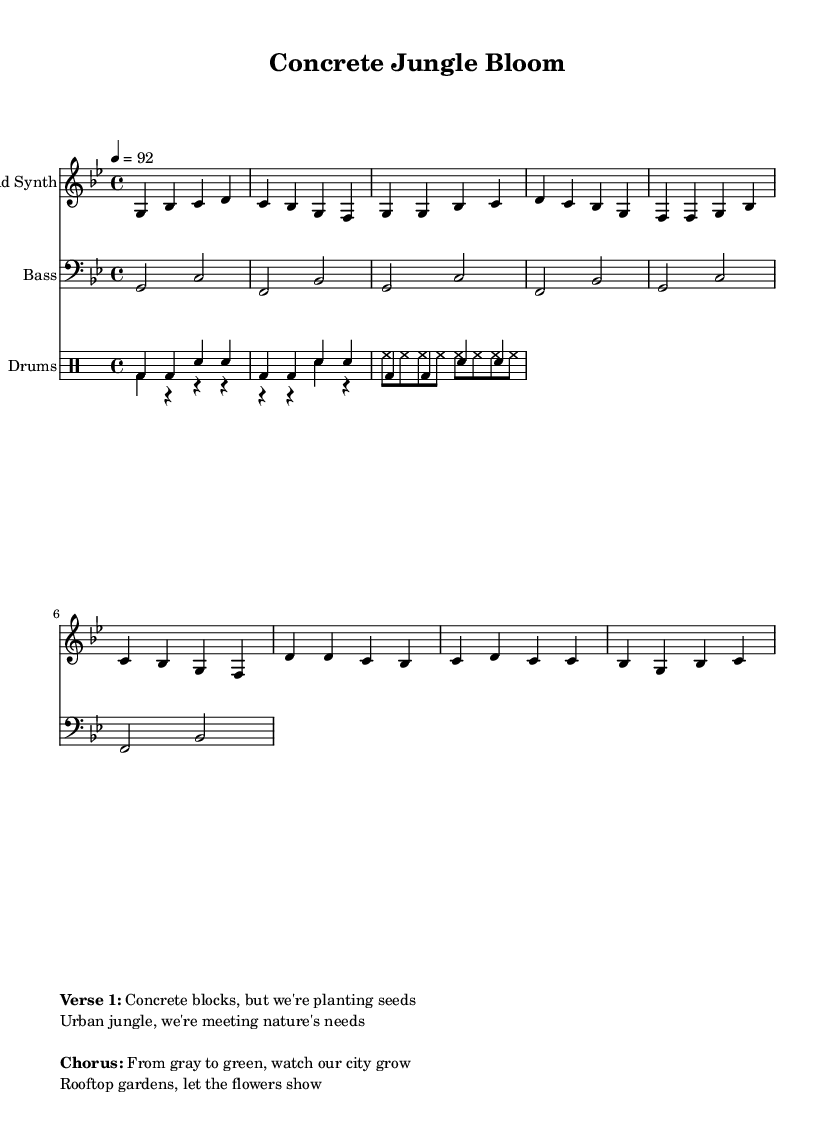What is the key signature of this music? The key signature of the music is indicated at the beginning of the score. Here, it shows two flats, meaning that it is in G minor.
Answer: G minor What is the time signature of this music? The time signature is located at the start of the piece and denotes the rhythmic structure. In this case, it is 4/4, which means there are four beats in a measure, and the quarter note gets one beat.
Answer: 4/4 What is the tempo marking of this piece? The tempo is specified near the beginning of the score with a numerical marking. It indicates that the piece should be played at a speed of 92 beats per minute.
Answer: 92 How many measures are in the verse section? To find this, we must count the measures in the "Verse" section of the lead synth part. There are a total of 8 measures in this section.
Answer: 8 What instruments are featured in this piece? The score includes a lead synth and bass as the melodic/rhythmic instruments, along with a drum set for percussion. We can see the labels for each in the score.
Answer: Lead Synth, Bass, Drums How many lines are in the chorus section, and what do they describe? In the chorus section, there are two lines of lyrics, which discuss the transformation from gray to green in the urban landscape and highlight rooftop gardens.
Answer: Two lines: From gray to green, watch our city grow; Rooftop gardens, let the flowers show What theme does this hip hop piece primarily address? The piece addresses the theme of urban gardening and the transformation of concrete jungles into green spaces. This is evident from the lyrics in both the verses and the chorus.
Answer: Urban gardening and transformation of concrete jungles 